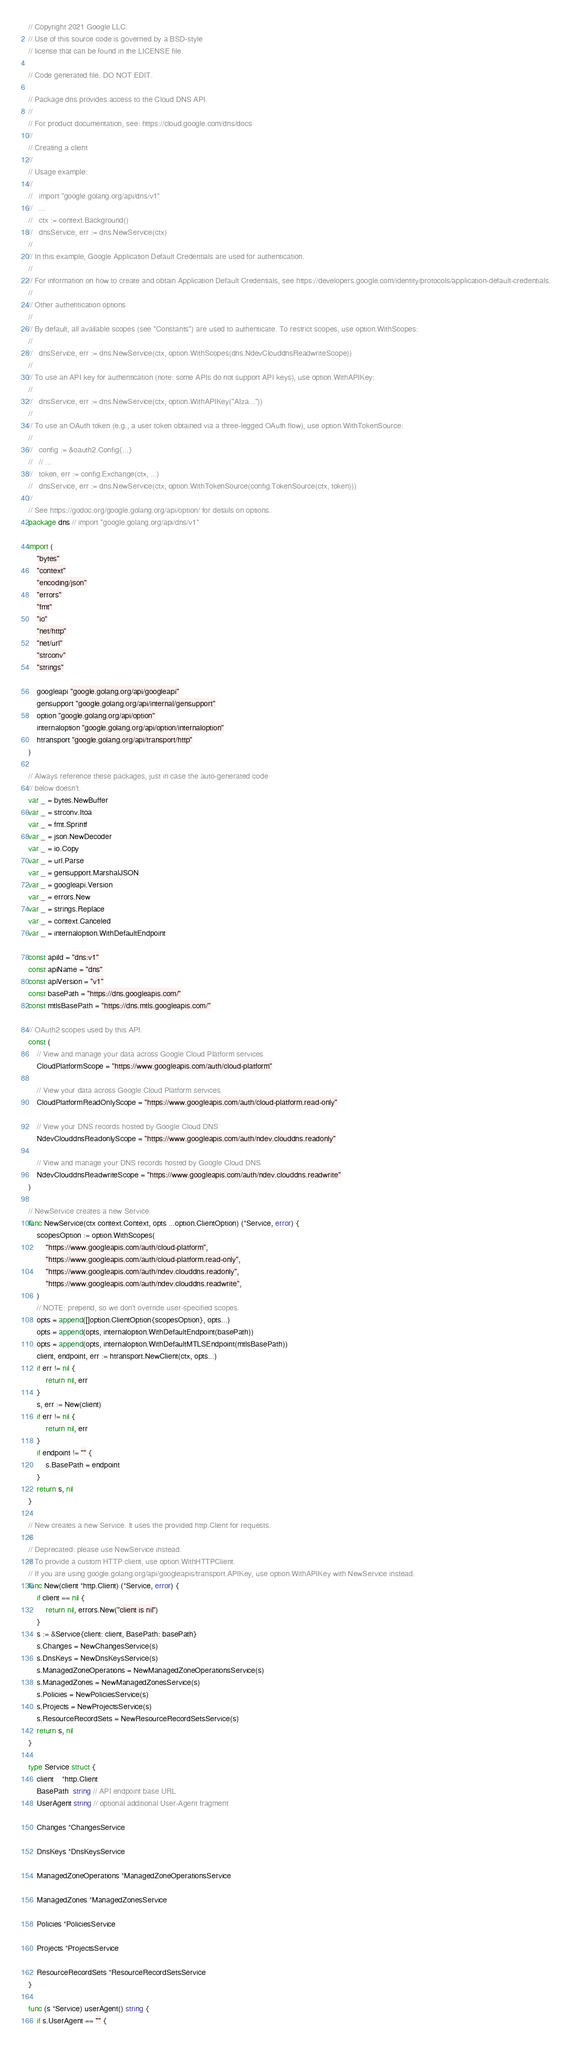Convert code to text. <code><loc_0><loc_0><loc_500><loc_500><_Go_>// Copyright 2021 Google LLC.
// Use of this source code is governed by a BSD-style
// license that can be found in the LICENSE file.

// Code generated file. DO NOT EDIT.

// Package dns provides access to the Cloud DNS API.
//
// For product documentation, see: https://cloud.google.com/dns/docs
//
// Creating a client
//
// Usage example:
//
//   import "google.golang.org/api/dns/v1"
//   ...
//   ctx := context.Background()
//   dnsService, err := dns.NewService(ctx)
//
// In this example, Google Application Default Credentials are used for authentication.
//
// For information on how to create and obtain Application Default Credentials, see https://developers.google.com/identity/protocols/application-default-credentials.
//
// Other authentication options
//
// By default, all available scopes (see "Constants") are used to authenticate. To restrict scopes, use option.WithScopes:
//
//   dnsService, err := dns.NewService(ctx, option.WithScopes(dns.NdevClouddnsReadwriteScope))
//
// To use an API key for authentication (note: some APIs do not support API keys), use option.WithAPIKey:
//
//   dnsService, err := dns.NewService(ctx, option.WithAPIKey("AIza..."))
//
// To use an OAuth token (e.g., a user token obtained via a three-legged OAuth flow), use option.WithTokenSource:
//
//   config := &oauth2.Config{...}
//   // ...
//   token, err := config.Exchange(ctx, ...)
//   dnsService, err := dns.NewService(ctx, option.WithTokenSource(config.TokenSource(ctx, token)))
//
// See https://godoc.org/google.golang.org/api/option/ for details on options.
package dns // import "google.golang.org/api/dns/v1"

import (
	"bytes"
	"context"
	"encoding/json"
	"errors"
	"fmt"
	"io"
	"net/http"
	"net/url"
	"strconv"
	"strings"

	googleapi "google.golang.org/api/googleapi"
	gensupport "google.golang.org/api/internal/gensupport"
	option "google.golang.org/api/option"
	internaloption "google.golang.org/api/option/internaloption"
	htransport "google.golang.org/api/transport/http"
)

// Always reference these packages, just in case the auto-generated code
// below doesn't.
var _ = bytes.NewBuffer
var _ = strconv.Itoa
var _ = fmt.Sprintf
var _ = json.NewDecoder
var _ = io.Copy
var _ = url.Parse
var _ = gensupport.MarshalJSON
var _ = googleapi.Version
var _ = errors.New
var _ = strings.Replace
var _ = context.Canceled
var _ = internaloption.WithDefaultEndpoint

const apiId = "dns:v1"
const apiName = "dns"
const apiVersion = "v1"
const basePath = "https://dns.googleapis.com/"
const mtlsBasePath = "https://dns.mtls.googleapis.com/"

// OAuth2 scopes used by this API.
const (
	// View and manage your data across Google Cloud Platform services
	CloudPlatformScope = "https://www.googleapis.com/auth/cloud-platform"

	// View your data across Google Cloud Platform services
	CloudPlatformReadOnlyScope = "https://www.googleapis.com/auth/cloud-platform.read-only"

	// View your DNS records hosted by Google Cloud DNS
	NdevClouddnsReadonlyScope = "https://www.googleapis.com/auth/ndev.clouddns.readonly"

	// View and manage your DNS records hosted by Google Cloud DNS
	NdevClouddnsReadwriteScope = "https://www.googleapis.com/auth/ndev.clouddns.readwrite"
)

// NewService creates a new Service.
func NewService(ctx context.Context, opts ...option.ClientOption) (*Service, error) {
	scopesOption := option.WithScopes(
		"https://www.googleapis.com/auth/cloud-platform",
		"https://www.googleapis.com/auth/cloud-platform.read-only",
		"https://www.googleapis.com/auth/ndev.clouddns.readonly",
		"https://www.googleapis.com/auth/ndev.clouddns.readwrite",
	)
	// NOTE: prepend, so we don't override user-specified scopes.
	opts = append([]option.ClientOption{scopesOption}, opts...)
	opts = append(opts, internaloption.WithDefaultEndpoint(basePath))
	opts = append(opts, internaloption.WithDefaultMTLSEndpoint(mtlsBasePath))
	client, endpoint, err := htransport.NewClient(ctx, opts...)
	if err != nil {
		return nil, err
	}
	s, err := New(client)
	if err != nil {
		return nil, err
	}
	if endpoint != "" {
		s.BasePath = endpoint
	}
	return s, nil
}

// New creates a new Service. It uses the provided http.Client for requests.
//
// Deprecated: please use NewService instead.
// To provide a custom HTTP client, use option.WithHTTPClient.
// If you are using google.golang.org/api/googleapis/transport.APIKey, use option.WithAPIKey with NewService instead.
func New(client *http.Client) (*Service, error) {
	if client == nil {
		return nil, errors.New("client is nil")
	}
	s := &Service{client: client, BasePath: basePath}
	s.Changes = NewChangesService(s)
	s.DnsKeys = NewDnsKeysService(s)
	s.ManagedZoneOperations = NewManagedZoneOperationsService(s)
	s.ManagedZones = NewManagedZonesService(s)
	s.Policies = NewPoliciesService(s)
	s.Projects = NewProjectsService(s)
	s.ResourceRecordSets = NewResourceRecordSetsService(s)
	return s, nil
}

type Service struct {
	client    *http.Client
	BasePath  string // API endpoint base URL
	UserAgent string // optional additional User-Agent fragment

	Changes *ChangesService

	DnsKeys *DnsKeysService

	ManagedZoneOperations *ManagedZoneOperationsService

	ManagedZones *ManagedZonesService

	Policies *PoliciesService

	Projects *ProjectsService

	ResourceRecordSets *ResourceRecordSetsService
}

func (s *Service) userAgent() string {
	if s.UserAgent == "" {</code> 